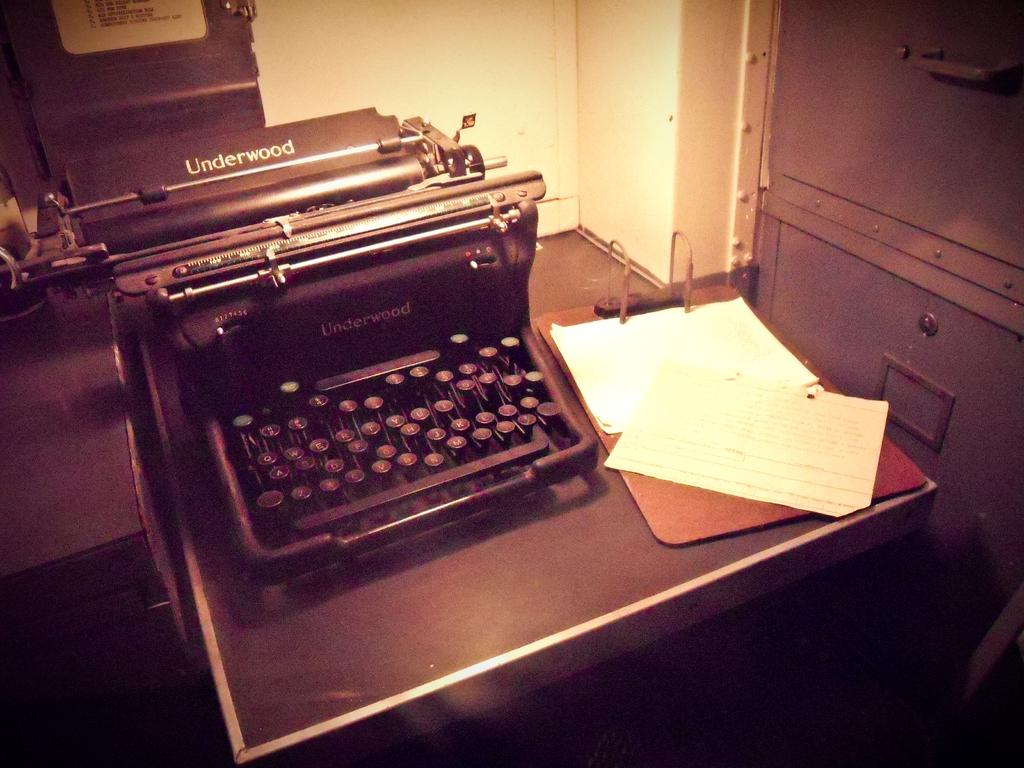<image>
Render a clear and concise summary of the photo. Typewrite that is from Underwood with a clipboard beside it that got paper on it 